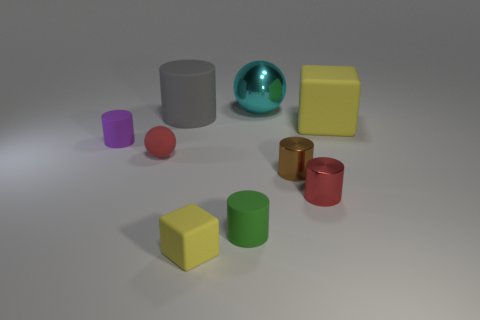Subtract all tiny brown cylinders. How many cylinders are left? 4 Subtract all green cylinders. How many cylinders are left? 4 Subtract 1 balls. How many balls are left? 1 Subtract all cylinders. How many objects are left? 4 Add 1 tiny purple rubber cylinders. How many objects exist? 10 Subtract all brown cubes. Subtract all red balls. How many cubes are left? 2 Subtract all large cyan things. Subtract all large yellow things. How many objects are left? 7 Add 1 large yellow rubber blocks. How many large yellow rubber blocks are left? 2 Add 3 red balls. How many red balls exist? 4 Subtract 1 brown cylinders. How many objects are left? 8 